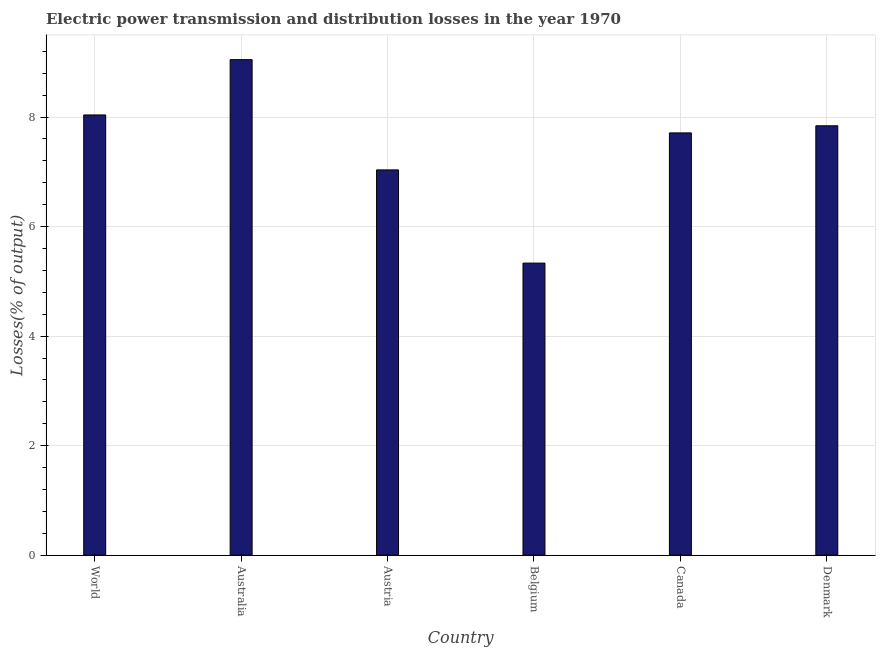Does the graph contain grids?
Make the answer very short. Yes. What is the title of the graph?
Your answer should be compact. Electric power transmission and distribution losses in the year 1970. What is the label or title of the X-axis?
Your answer should be very brief. Country. What is the label or title of the Y-axis?
Provide a succinct answer. Losses(% of output). What is the electric power transmission and distribution losses in Austria?
Your answer should be very brief. 7.04. Across all countries, what is the maximum electric power transmission and distribution losses?
Offer a terse response. 9.05. Across all countries, what is the minimum electric power transmission and distribution losses?
Offer a very short reply. 5.33. In which country was the electric power transmission and distribution losses maximum?
Your response must be concise. Australia. What is the sum of the electric power transmission and distribution losses?
Your answer should be compact. 45.01. What is the difference between the electric power transmission and distribution losses in Australia and Canada?
Keep it short and to the point. 1.34. What is the average electric power transmission and distribution losses per country?
Your response must be concise. 7.5. What is the median electric power transmission and distribution losses?
Your answer should be compact. 7.78. What is the ratio of the electric power transmission and distribution losses in Denmark to that in World?
Your answer should be compact. 0.97. What is the difference between the highest and the lowest electric power transmission and distribution losses?
Make the answer very short. 3.71. What is the Losses(% of output) of World?
Your answer should be very brief. 8.04. What is the Losses(% of output) in Australia?
Your response must be concise. 9.05. What is the Losses(% of output) of Austria?
Keep it short and to the point. 7.04. What is the Losses(% of output) of Belgium?
Provide a succinct answer. 5.33. What is the Losses(% of output) in Canada?
Ensure brevity in your answer.  7.71. What is the Losses(% of output) of Denmark?
Make the answer very short. 7.84. What is the difference between the Losses(% of output) in World and Australia?
Provide a succinct answer. -1.01. What is the difference between the Losses(% of output) in World and Austria?
Provide a succinct answer. 1. What is the difference between the Losses(% of output) in World and Belgium?
Provide a short and direct response. 2.71. What is the difference between the Losses(% of output) in World and Canada?
Give a very brief answer. 0.33. What is the difference between the Losses(% of output) in World and Denmark?
Offer a very short reply. 0.2. What is the difference between the Losses(% of output) in Australia and Austria?
Give a very brief answer. 2.01. What is the difference between the Losses(% of output) in Australia and Belgium?
Your answer should be compact. 3.71. What is the difference between the Losses(% of output) in Australia and Canada?
Your response must be concise. 1.34. What is the difference between the Losses(% of output) in Australia and Denmark?
Offer a terse response. 1.21. What is the difference between the Losses(% of output) in Austria and Belgium?
Provide a succinct answer. 1.7. What is the difference between the Losses(% of output) in Austria and Canada?
Keep it short and to the point. -0.68. What is the difference between the Losses(% of output) in Austria and Denmark?
Give a very brief answer. -0.81. What is the difference between the Losses(% of output) in Belgium and Canada?
Your response must be concise. -2.38. What is the difference between the Losses(% of output) in Belgium and Denmark?
Keep it short and to the point. -2.51. What is the difference between the Losses(% of output) in Canada and Denmark?
Provide a short and direct response. -0.13. What is the ratio of the Losses(% of output) in World to that in Australia?
Your answer should be compact. 0.89. What is the ratio of the Losses(% of output) in World to that in Austria?
Provide a short and direct response. 1.14. What is the ratio of the Losses(% of output) in World to that in Belgium?
Offer a terse response. 1.51. What is the ratio of the Losses(% of output) in World to that in Canada?
Keep it short and to the point. 1.04. What is the ratio of the Losses(% of output) in World to that in Denmark?
Ensure brevity in your answer.  1.02. What is the ratio of the Losses(% of output) in Australia to that in Austria?
Give a very brief answer. 1.29. What is the ratio of the Losses(% of output) in Australia to that in Belgium?
Give a very brief answer. 1.7. What is the ratio of the Losses(% of output) in Australia to that in Canada?
Your answer should be very brief. 1.17. What is the ratio of the Losses(% of output) in Australia to that in Denmark?
Ensure brevity in your answer.  1.15. What is the ratio of the Losses(% of output) in Austria to that in Belgium?
Keep it short and to the point. 1.32. What is the ratio of the Losses(% of output) in Austria to that in Canada?
Make the answer very short. 0.91. What is the ratio of the Losses(% of output) in Austria to that in Denmark?
Provide a short and direct response. 0.9. What is the ratio of the Losses(% of output) in Belgium to that in Canada?
Offer a terse response. 0.69. What is the ratio of the Losses(% of output) in Belgium to that in Denmark?
Provide a short and direct response. 0.68. What is the ratio of the Losses(% of output) in Canada to that in Denmark?
Provide a short and direct response. 0.98. 